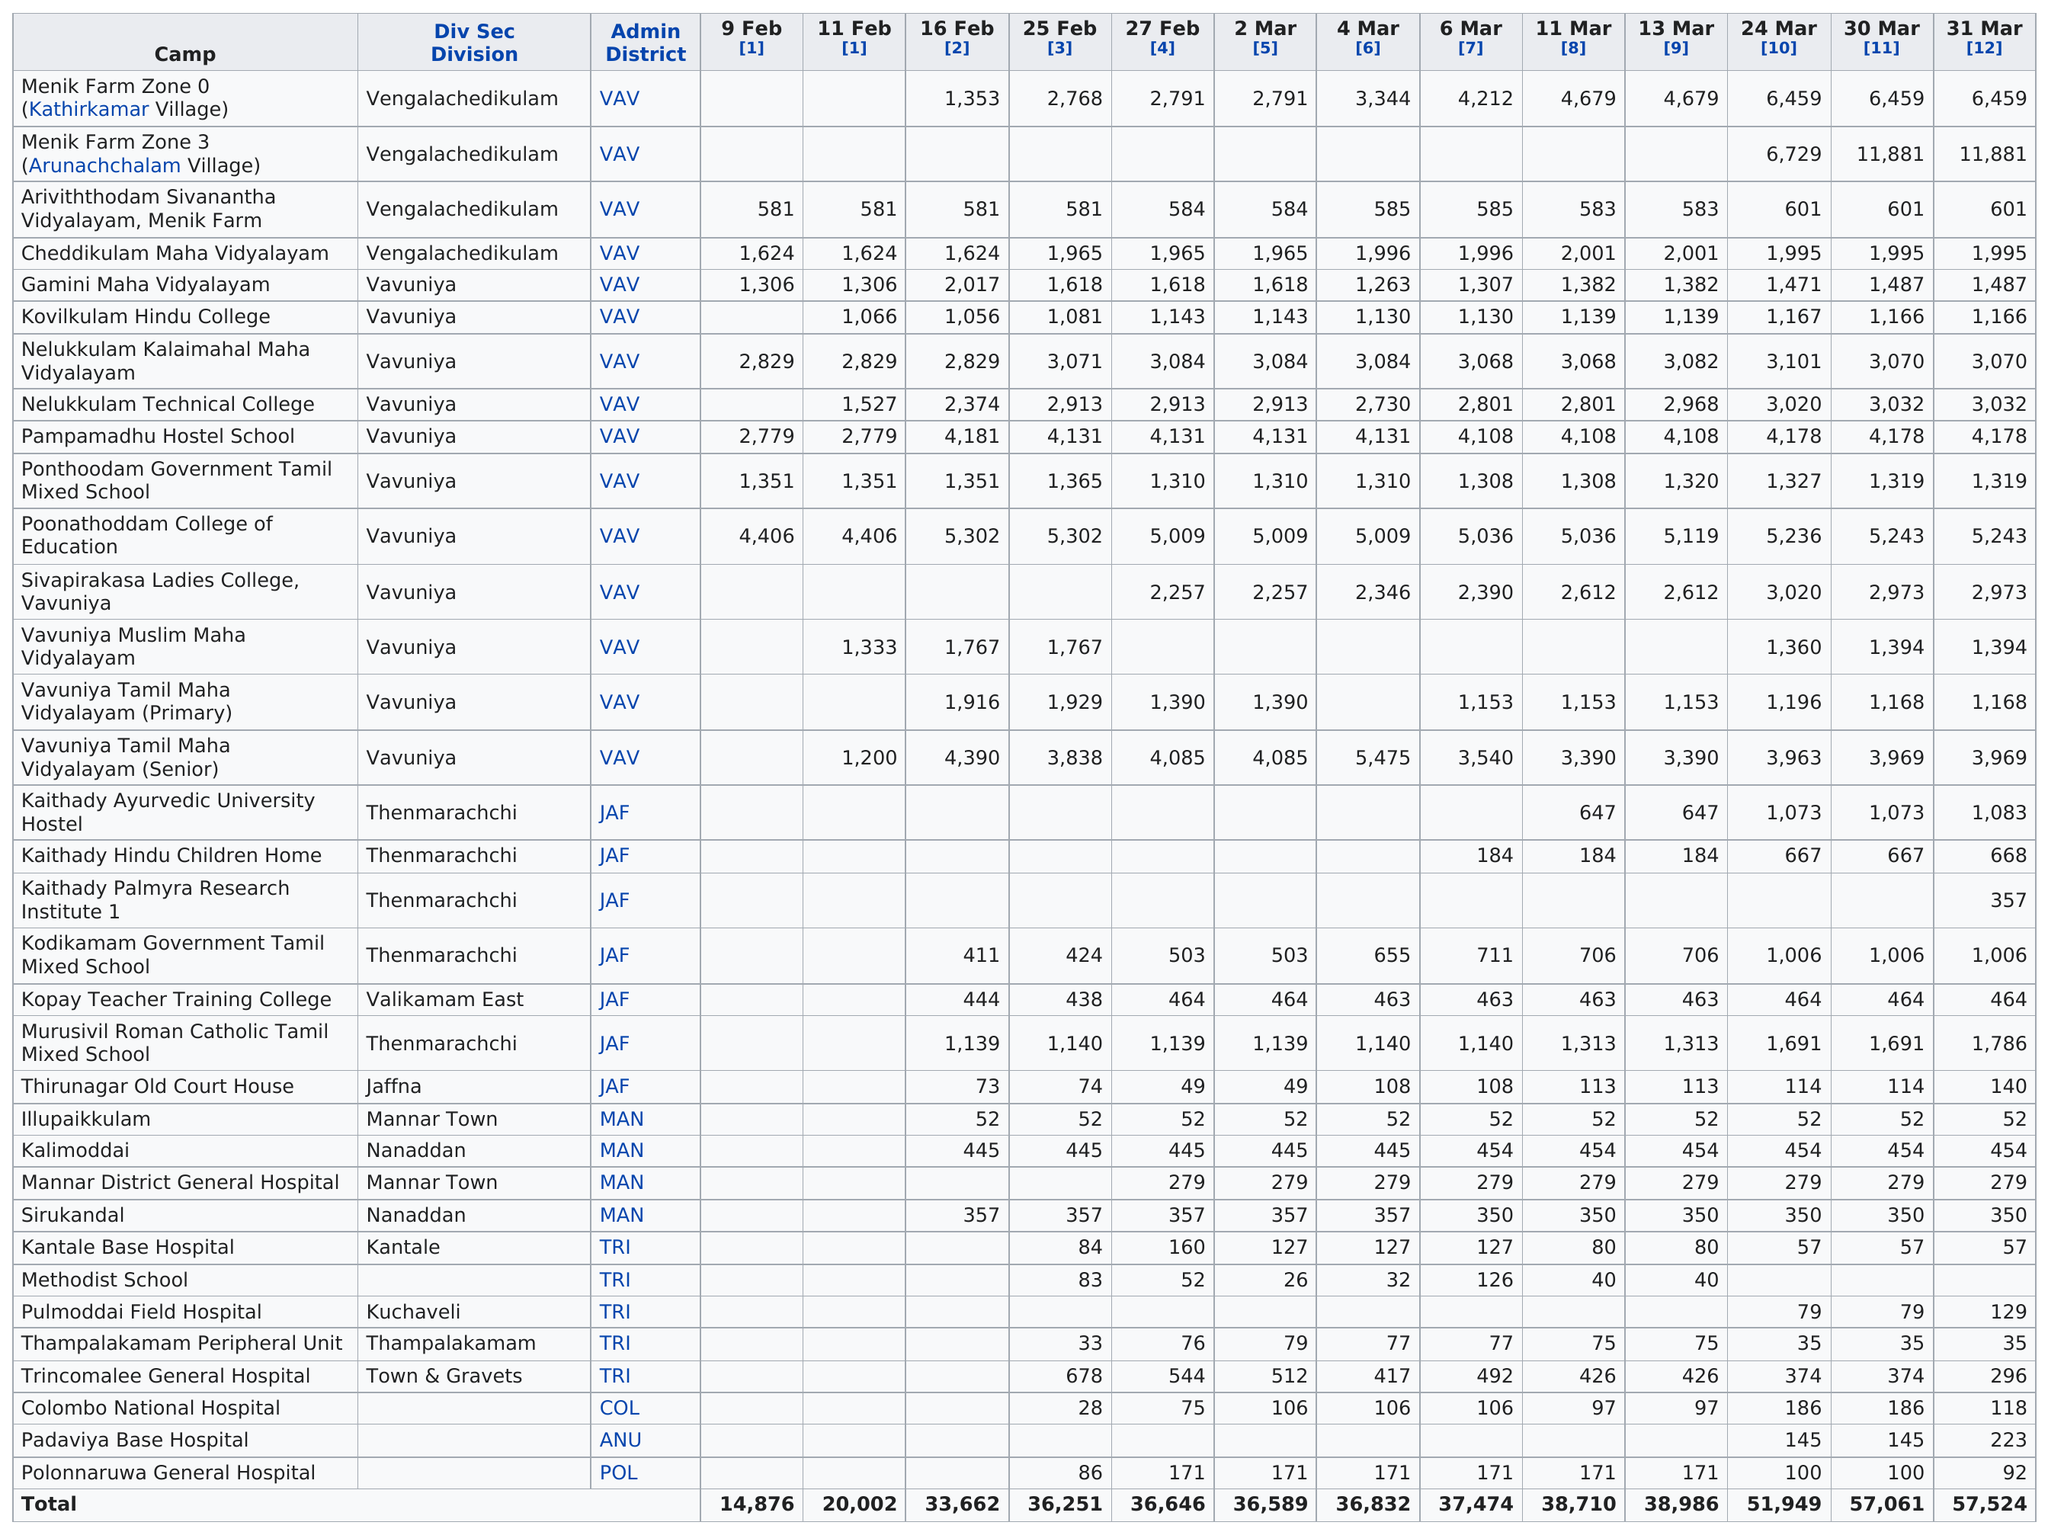Draw attention to some important aspects in this diagram. On February 9th, Poonathoddam College of Education was ranked as the top camp. The division that comes after Jaffna is [insert name of division], and Mannar Town is located in [insert name of division]. On February 9, a total of 7 locations recorded IDPS. On March 11th and 13th, the Colombo National Hospital received more than 75 but less than 100 IDPS. The Kodikamam Government Tamil Mixed School has gone for 500 days without topping any IDPs as of 25 February [3]. 